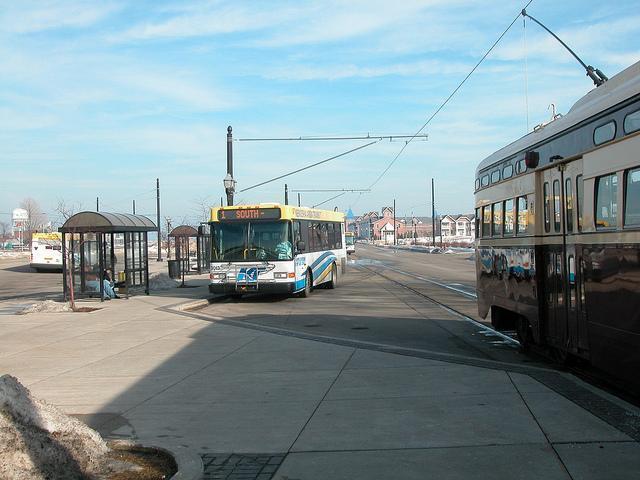How many buses are in the picture?
Give a very brief answer. 2. How many people are wearing orange shirts in the picture?
Give a very brief answer. 0. 